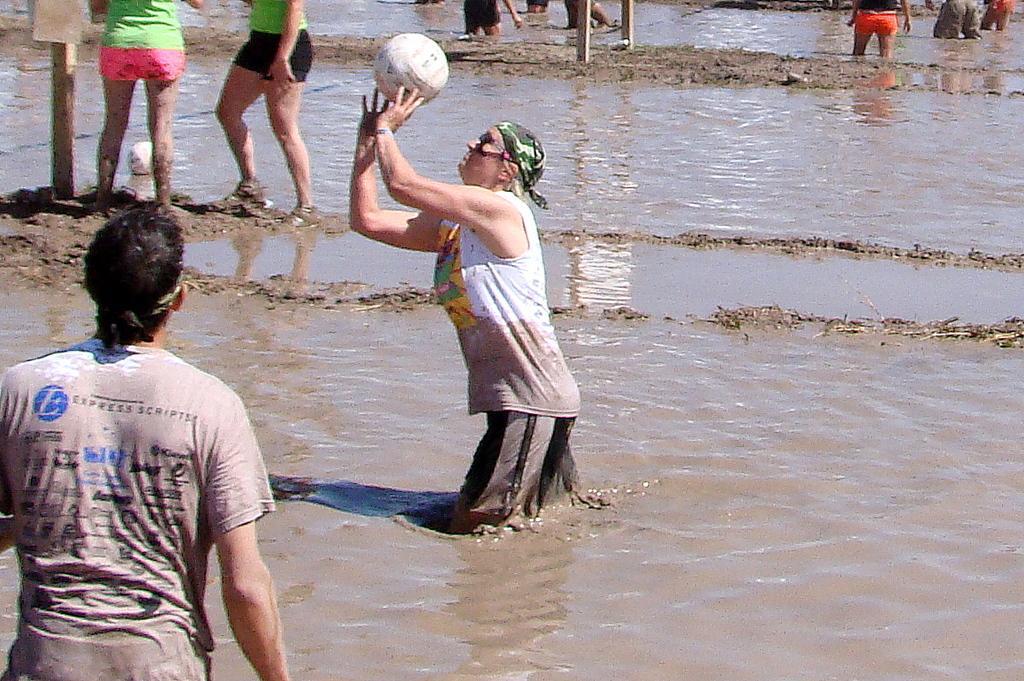Describe this image in one or two sentences. In the foreground of this image, there are persons standing in the mud water and also a man throwing a ball. In the background, there are persons standing in the mud water and we can also see two wooden poles. 